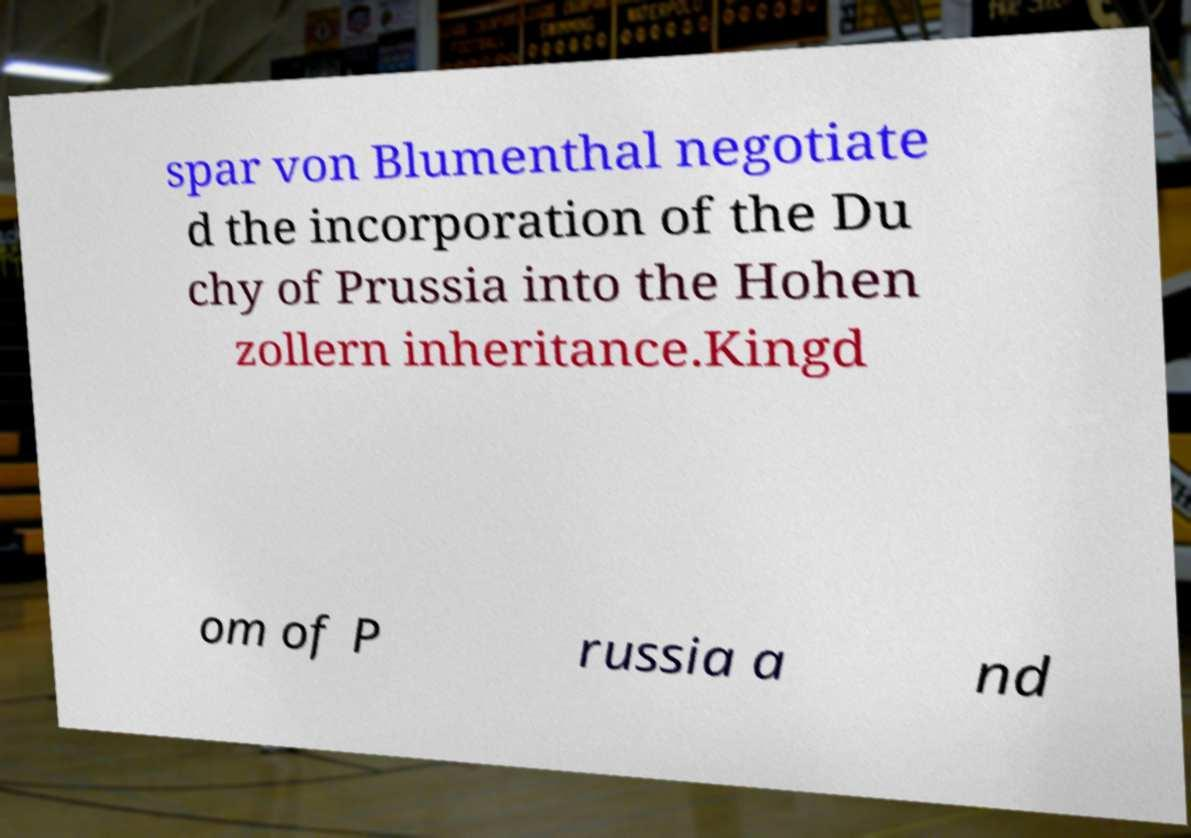Can you read and provide the text displayed in the image?This photo seems to have some interesting text. Can you extract and type it out for me? spar von Blumenthal negotiate d the incorporation of the Du chy of Prussia into the Hohen zollern inheritance.Kingd om of P russia a nd 